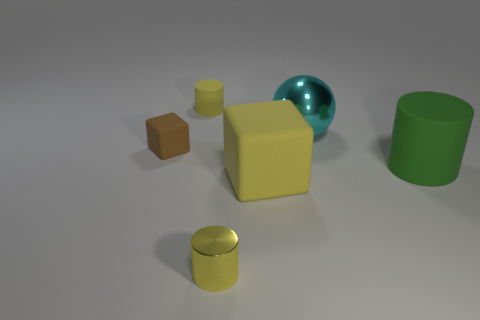There is a big thing that is on the left side of the big cylinder and behind the big yellow block; what material is it made of? metal 